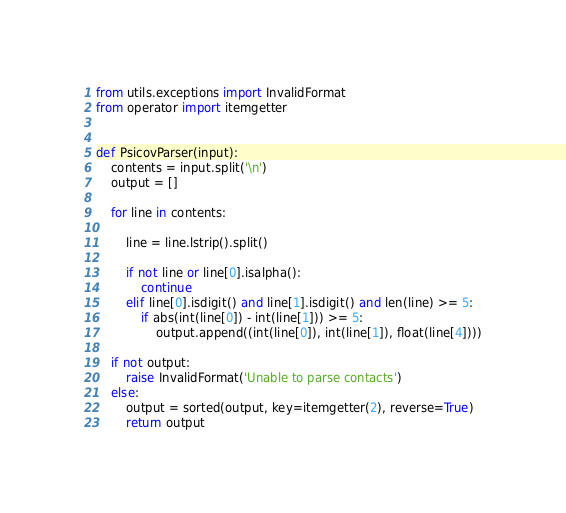Convert code to text. <code><loc_0><loc_0><loc_500><loc_500><_Python_>from utils.exceptions import InvalidFormat
from operator import itemgetter


def PsicovParser(input):
    contents = input.split('\n')
    output = []

    for line in contents:

        line = line.lstrip().split()

        if not line or line[0].isalpha():
            continue
        elif line[0].isdigit() and line[1].isdigit() and len(line) >= 5:
            if abs(int(line[0]) - int(line[1])) >= 5:
                output.append((int(line[0]), int(line[1]), float(line[4])))

    if not output:
        raise InvalidFormat('Unable to parse contacts')
    else:
        output = sorted(output, key=itemgetter(2), reverse=True)
        return output

</code> 